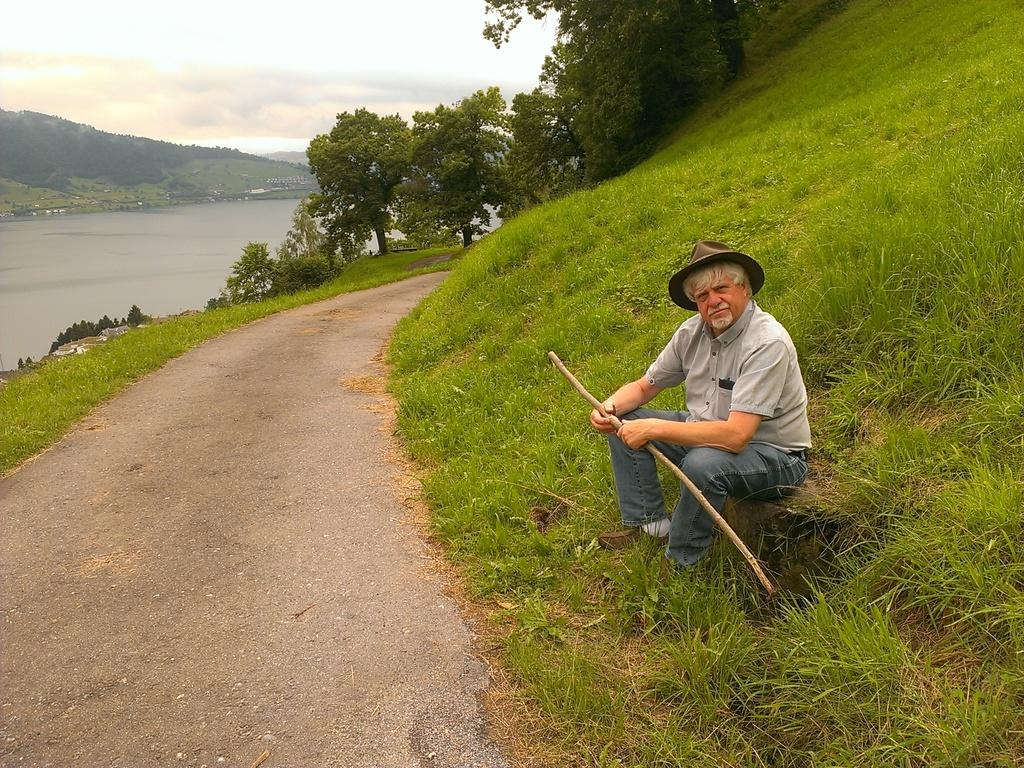What is the main subject of the image? There is a person in the image. What is the person holding in the image? The person is holding a stick. What can be seen in front of the person? There is a road in front of the person. What type of natural environment is visible in the background of the image? There is grass, water, and trees in the background of the image. What else can be seen in the background of the image? The sky and some objects are visible in the background of the image. What type of experience can be gained by joining the test in the image? There is no test or indication of an experience to be gained in the image. 